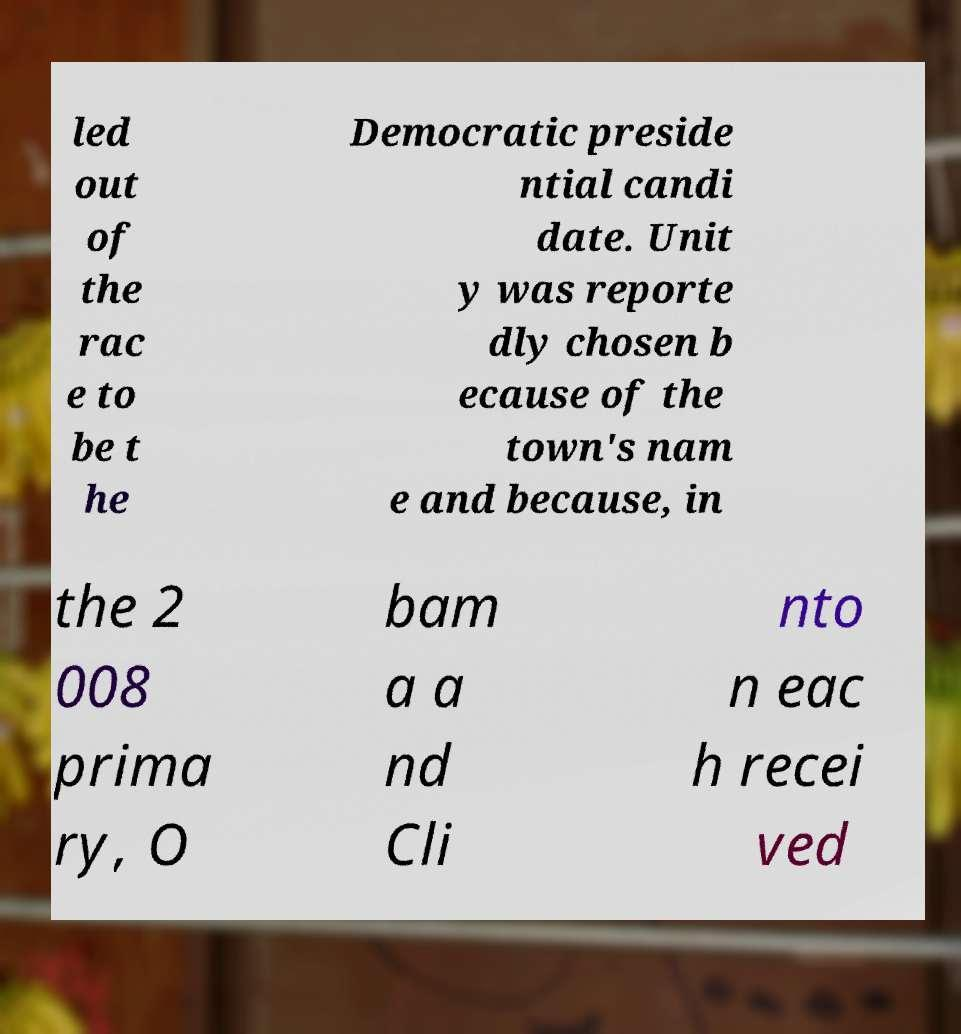For documentation purposes, I need the text within this image transcribed. Could you provide that? led out of the rac e to be t he Democratic preside ntial candi date. Unit y was reporte dly chosen b ecause of the town's nam e and because, in the 2 008 prima ry, O bam a a nd Cli nto n eac h recei ved 